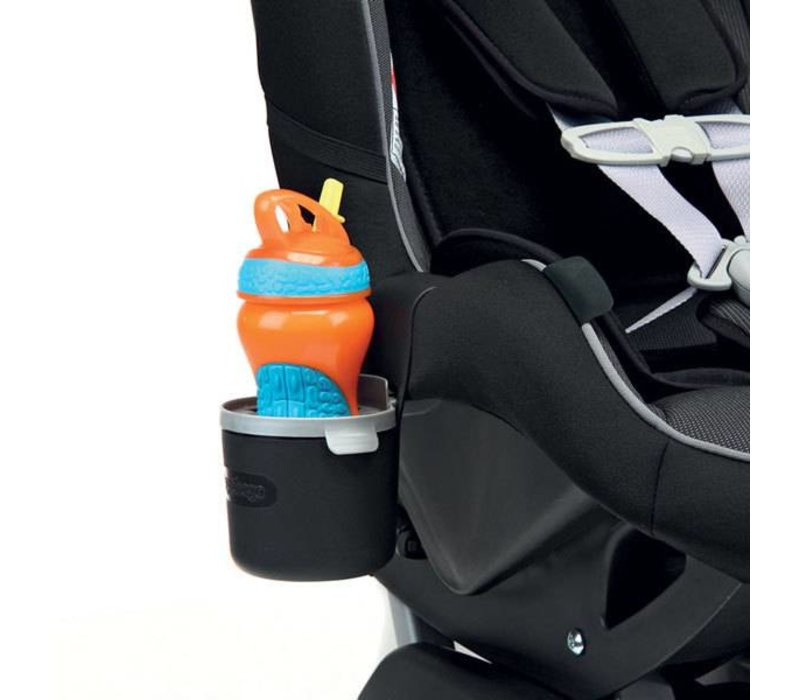Considering the design and features of the car seat and the sippy cup, what can be inferred about the considerations taken into account for the safety and comfort of a child while traveling in a vehicle? The car seat in the image is designed with a robust five-point harness system, which is crucial for securing the child safely while accommodating growth through adjustable straps. The seat's cushioning appears ample, providing comfort and reducing fatigue during long rides. The material likely includes a breathable fabric to prevent discomfort from overheating. Attention to child accessibility and minimal driver distraction is evident in the integration of a cup holder placed within easy reach for a child. The sippy cup features a bendable straw and a secure lid to prevent spills, thereby maintaining cleanliness and safety by keeping the driver's attention undiverted from the road. 